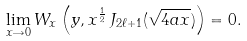<formula> <loc_0><loc_0><loc_500><loc_500>\lim _ { x \rightarrow 0 } W _ { x } \left ( y , x ^ { \frac { 1 } { 2 } } \, J _ { 2 \ell + 1 } ( \sqrt { 4 a x } ) \right ) = 0 .</formula> 